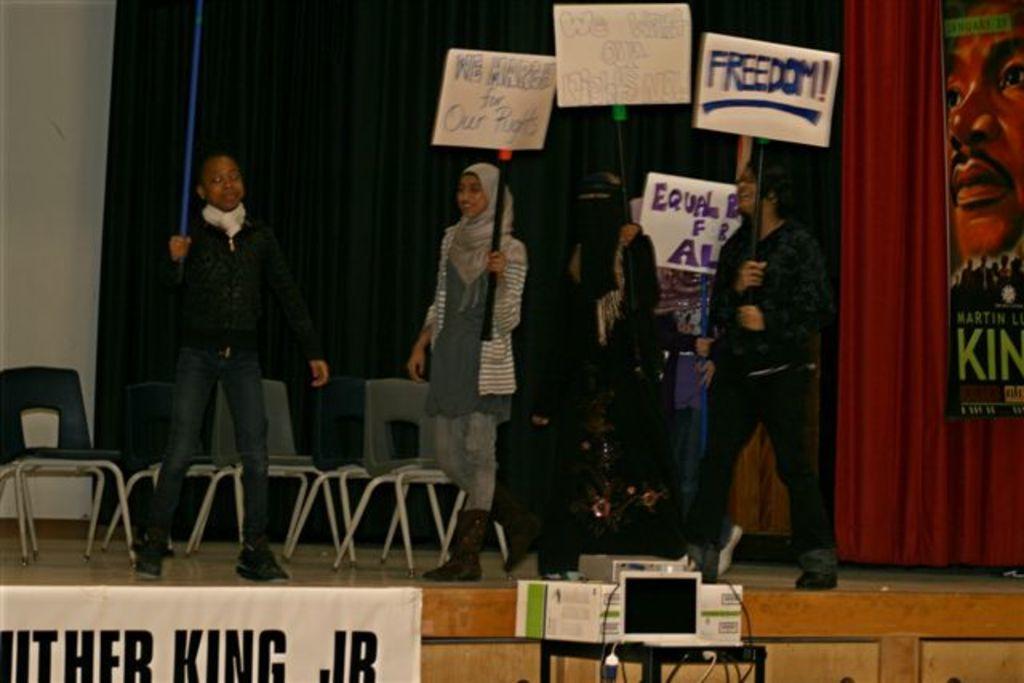Can you describe this image briefly? There are four persons on the floor. Three persons are holding hoardings. In front of them, there is device on the stool. And there is a poster attached to this stage. In the background, there is a violet color curtain. On the right hand side of the image, there is a poster on the brown color curtain. On the left hand side of the image, there is white color wall and a chair. 